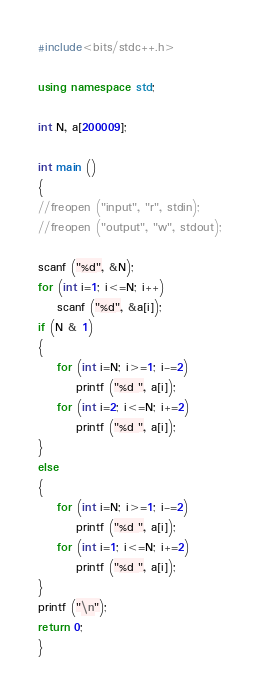<code> <loc_0><loc_0><loc_500><loc_500><_C++_>#include<bits/stdc++.h>

using namespace std;

int N, a[200009];

int main ()
{
//freopen ("input", "r", stdin);
//freopen ("output", "w", stdout);

scanf ("%d", &N);
for (int i=1; i<=N; i++)
    scanf ("%d", &a[i]);
if (N & 1)
{
    for (int i=N; i>=1; i-=2)
        printf ("%d ", a[i]);
    for (int i=2; i<=N; i+=2)
        printf ("%d ", a[i]);
}
else
{
    for (int i=N; i>=1; i-=2)
        printf ("%d ", a[i]);
    for (int i=1; i<=N; i+=2)
        printf ("%d ", a[i]);
}
printf ("\n");
return 0;
}
</code> 